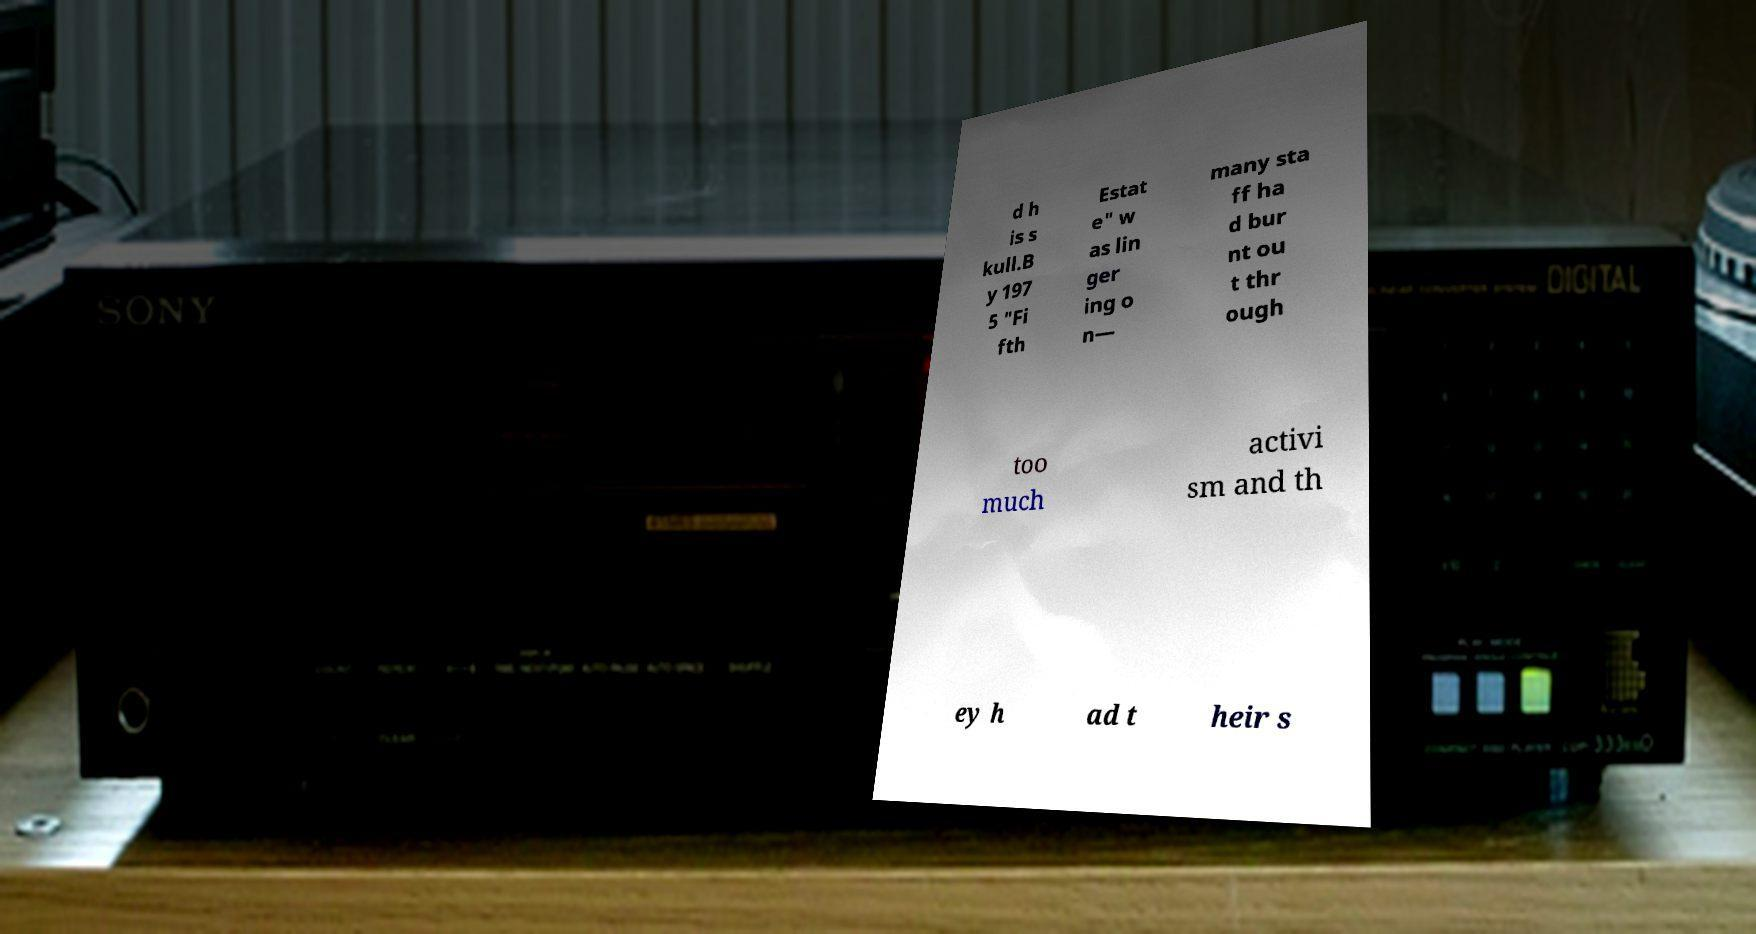Please identify and transcribe the text found in this image. d h is s kull.B y 197 5 "Fi fth Estat e" w as lin ger ing o n— many sta ff ha d bur nt ou t thr ough too much activi sm and th ey h ad t heir s 